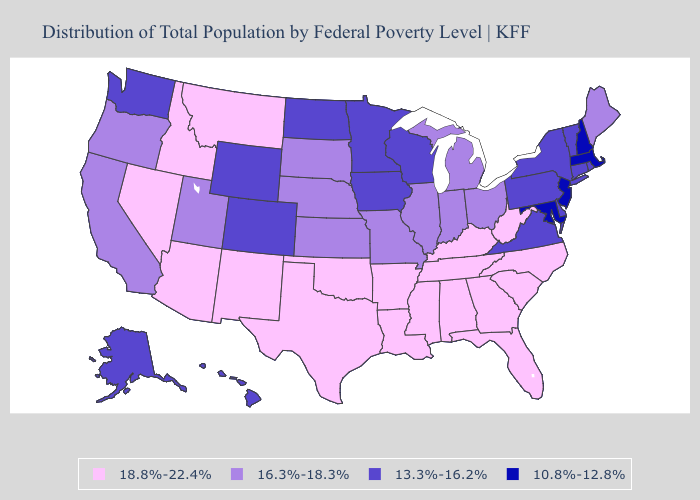Among the states that border Wisconsin , which have the highest value?
Keep it brief. Illinois, Michigan. What is the highest value in the Northeast ?
Write a very short answer. 16.3%-18.3%. Does Indiana have the same value as New Hampshire?
Answer briefly. No. Does the map have missing data?
Concise answer only. No. Name the states that have a value in the range 13.3%-16.2%?
Answer briefly. Alaska, Colorado, Connecticut, Delaware, Hawaii, Iowa, Minnesota, New York, North Dakota, Pennsylvania, Rhode Island, Vermont, Virginia, Washington, Wisconsin, Wyoming. Name the states that have a value in the range 13.3%-16.2%?
Concise answer only. Alaska, Colorado, Connecticut, Delaware, Hawaii, Iowa, Minnesota, New York, North Dakota, Pennsylvania, Rhode Island, Vermont, Virginia, Washington, Wisconsin, Wyoming. What is the highest value in states that border Ohio?
Short answer required. 18.8%-22.4%. Does the map have missing data?
Quick response, please. No. Name the states that have a value in the range 13.3%-16.2%?
Concise answer only. Alaska, Colorado, Connecticut, Delaware, Hawaii, Iowa, Minnesota, New York, North Dakota, Pennsylvania, Rhode Island, Vermont, Virginia, Washington, Wisconsin, Wyoming. Name the states that have a value in the range 16.3%-18.3%?
Keep it brief. California, Illinois, Indiana, Kansas, Maine, Michigan, Missouri, Nebraska, Ohio, Oregon, South Dakota, Utah. Among the states that border Connecticut , does Massachusetts have the highest value?
Short answer required. No. What is the lowest value in the West?
Answer briefly. 13.3%-16.2%. Name the states that have a value in the range 10.8%-12.8%?
Give a very brief answer. Maryland, Massachusetts, New Hampshire, New Jersey. Name the states that have a value in the range 18.8%-22.4%?
Concise answer only. Alabama, Arizona, Arkansas, Florida, Georgia, Idaho, Kentucky, Louisiana, Mississippi, Montana, Nevada, New Mexico, North Carolina, Oklahoma, South Carolina, Tennessee, Texas, West Virginia. Does New Jersey have the lowest value in the USA?
Concise answer only. Yes. 